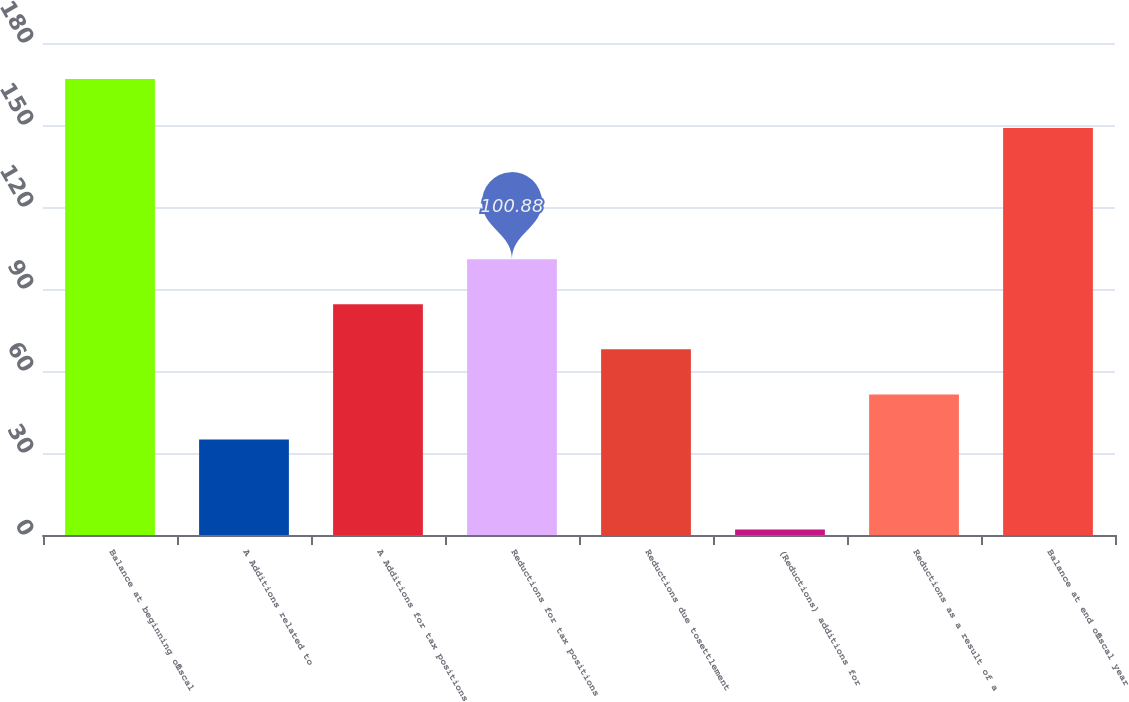Convert chart to OTSL. <chart><loc_0><loc_0><loc_500><loc_500><bar_chart><fcel>Balance at beginning offiscal<fcel>A Additions related to<fcel>A Additions for tax positions<fcel>Reductions for tax positions<fcel>Reductions due tosettlement<fcel>(Reductions) additions for<fcel>Reductions as a result of a<fcel>Balance at end offiscal year<nl><fcel>166.8<fcel>34.96<fcel>84.4<fcel>100.88<fcel>67.92<fcel>2<fcel>51.44<fcel>148.9<nl></chart> 